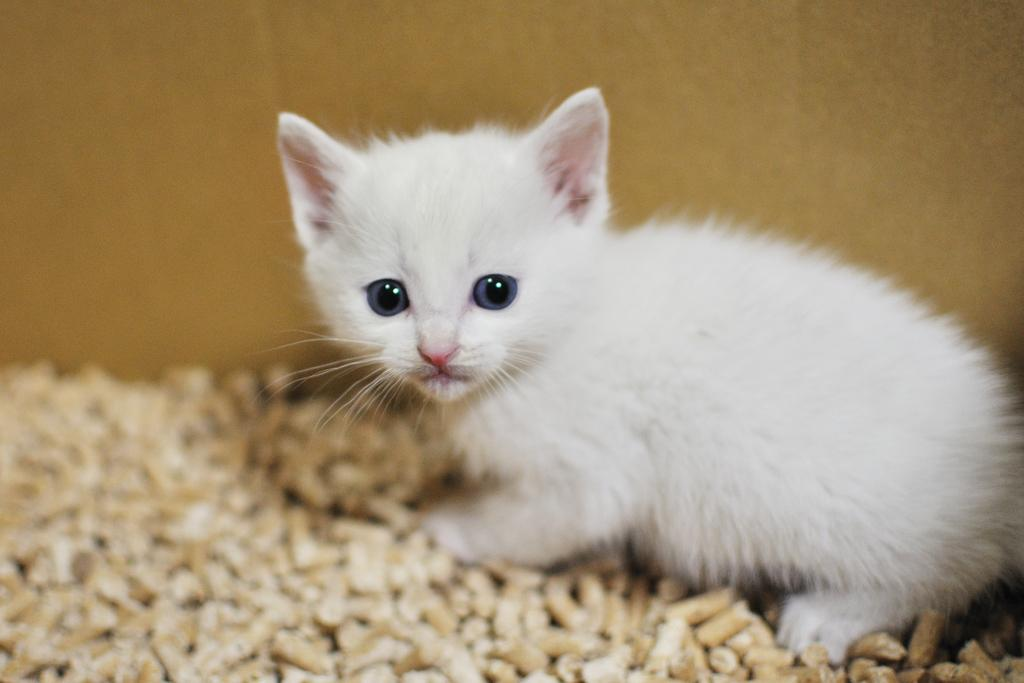What type of animal is in the image? There is a white cat in the image. What is behind the cat in the image? There is a wall behind the cat. What type of music is the cat playing in the image? There is no music or instrument present in the image; it only features a white cat and a wall. 